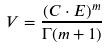Convert formula to latex. <formula><loc_0><loc_0><loc_500><loc_500>V = \frac { ( C \cdot E ) ^ { m } } { \Gamma ( m + 1 ) }</formula> 